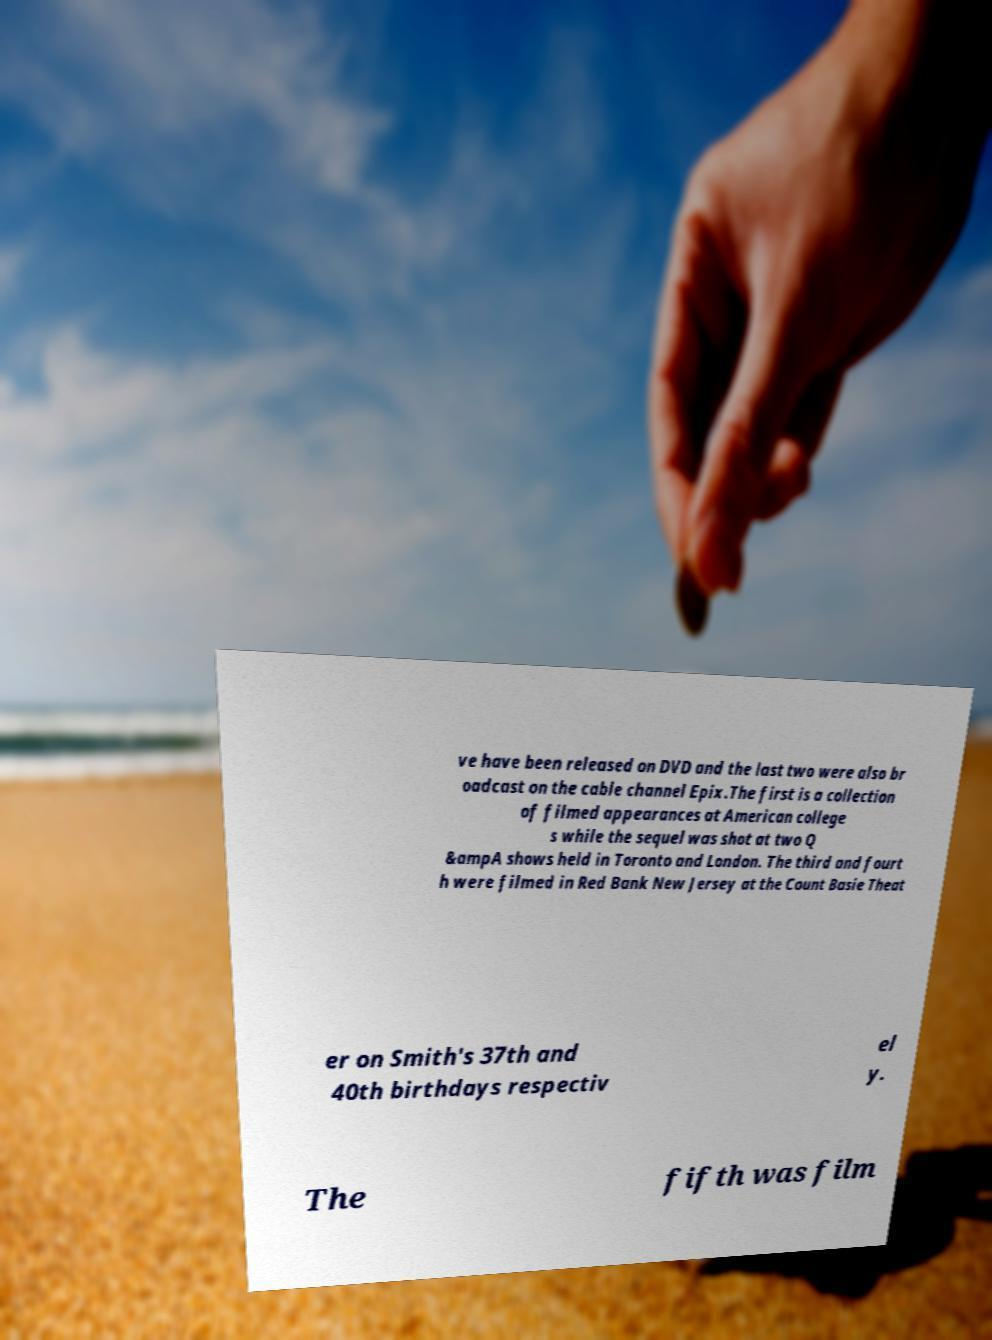For documentation purposes, I need the text within this image transcribed. Could you provide that? ve have been released on DVD and the last two were also br oadcast on the cable channel Epix.The first is a collection of filmed appearances at American college s while the sequel was shot at two Q &ampA shows held in Toronto and London. The third and fourt h were filmed in Red Bank New Jersey at the Count Basie Theat er on Smith's 37th and 40th birthdays respectiv el y. The fifth was film 